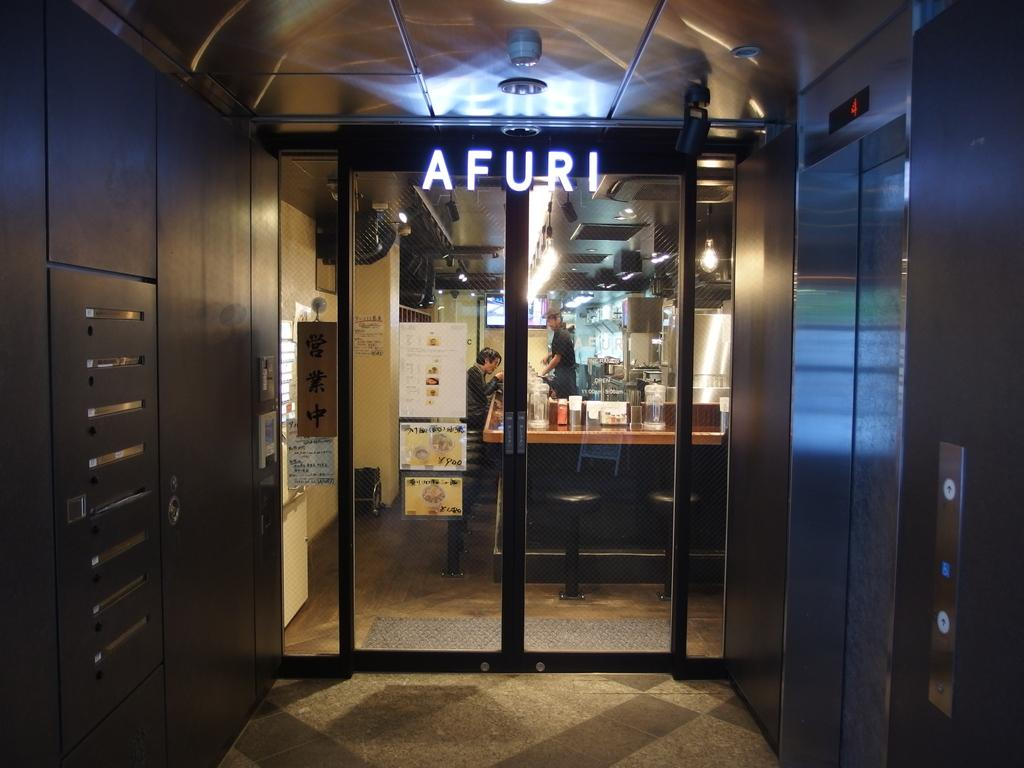<image>
Relay a brief, clear account of the picture shown. Two people are visible inside an Afuri store. 